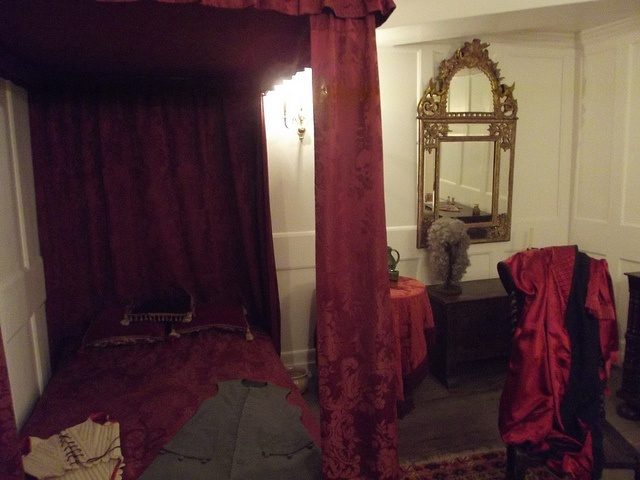Describe the objects in this image and their specific colors. I can see bed in black, maroon, gray, and white tones and chair in black and maroon tones in this image. 